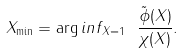<formula> <loc_0><loc_0><loc_500><loc_500>X _ { \min } = \arg i n f _ { \| X \| = 1 } \ \frac { \tilde { \phi } ( X ) } { \chi ( X ) } .</formula> 